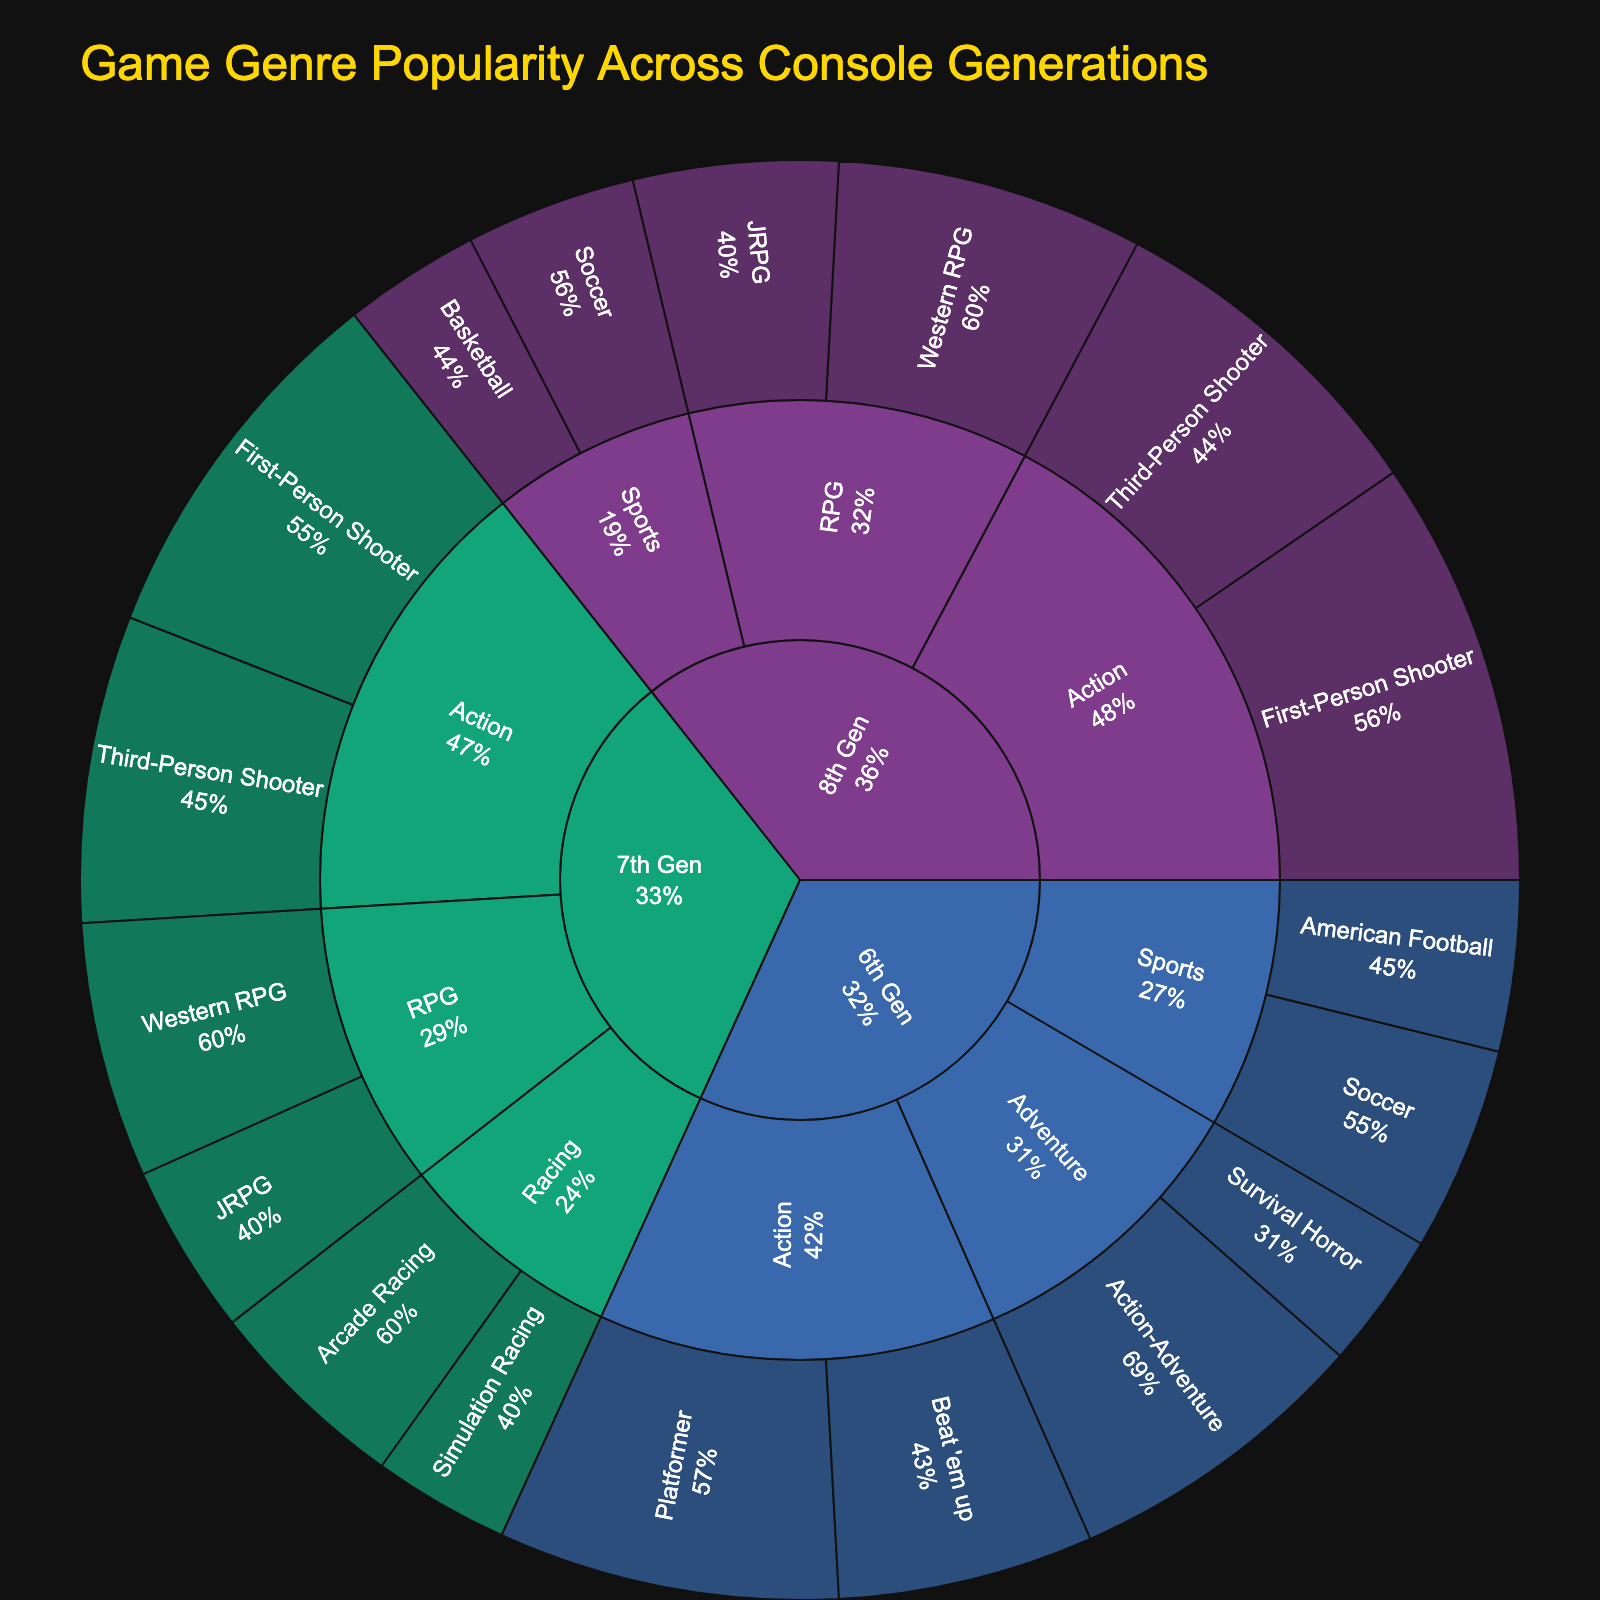What is the title of the figure? The title is displayed prominently at the top of the plot. It summarizes the content of the visual representation.
Answer: Game Genre Popularity Across Console Generations Which console generation shows the highest popularity for 'First-Person Shooter' games? Look at the 'Action' category under each console generation, then find the subgenre 'First-Person Shooter' within each one, and compare the popularity values.
Answer: 8th Gen What's the total popularity of 'RPG' games in the 8th Gen? Locate the 'RPG' genre in the 8th Gen section, then sum the popularity values of its subgenres: 'Western RPG' and 'JRPG'.
Answer: 30 How do the popularity values of 'Soccer' games compare between the 6th Gen and the 8th Gen? Locate 'Soccer' under the 'Sports' genre for both the 6th and 8th Gen. Compare their popularity values directly.
Answer: 8th Gen has 10, 6th Gen has 12; thus 6th Gen is higher Which genre in the 7th Gen has the lowest popularity? Examine each genre in the 7th Gen and find the one with the lowest total popularity by summing the subgenre values in each genre.
Answer: Racing Overall, which generation shows the highest diversity in game genres? Assess the number of unique genres within each generation section of the plot.
Answer: 6th Gen What percentage of the total popularity does 'Third-Person Shooter' represent in the 7th Gen? Find the popularity of 'Third-Person Shooter' in the 7th Gen and calculate its percentage of the total popularity for the 7th Gen. Sum all subgenre values within 7th Gen and use this sum for percentage calculation.
Answer: (18/85) * 100 ≈ 21.18% What's the most popular subgenre in the 6th Gen and what is its popularity? Explore all the subgenres in the 6th Gen section and identify the one with the highest popularity value.
Answer: Platformer, with a popularity of 20 How does the popularity of 'Western RPG' games evolve from the 7th Gen to the 8th Gen? Compare the popularity values of 'Western RPG' games in the 7th Gen and 8th Gen sections.
Answer: Increased from 15 to 18 What's the ratio of popularity between 'Action-Adventure' and 'Survival Horror' in the 6th Gen? Identify the popularity values of 'Action-Adventure' and 'Survival Horror' in the 6th Gen, then compute their ratio.
Answer: 18:8 